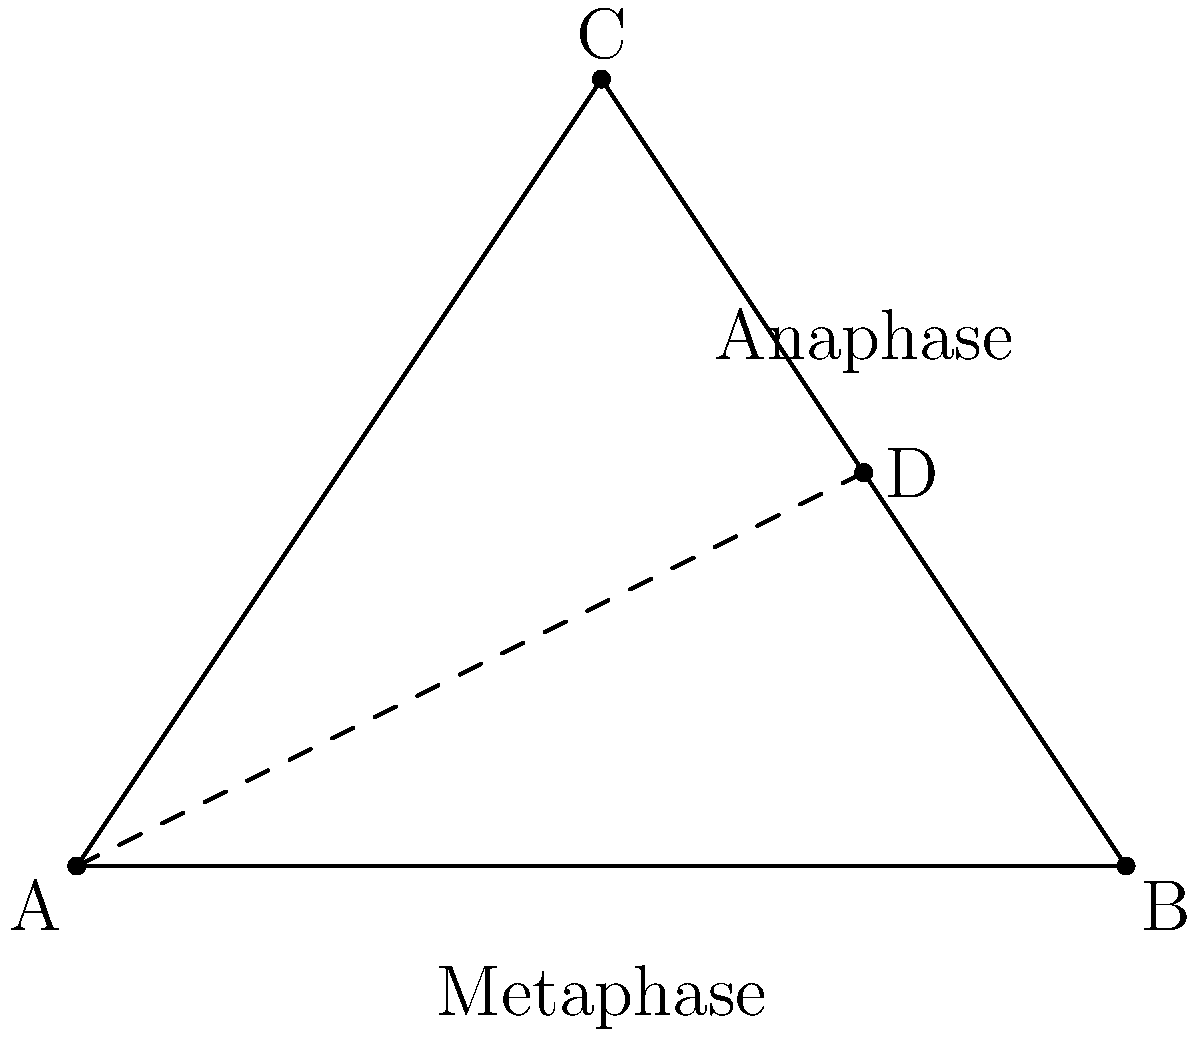In a novel exploring cellular biology, you describe the process of mitosis using geometric analogies. Consider the triangle ABC representing a cell at metaphase, with point D being the midpoint of BC. If the distance from A to D represents the movement of chromosomes during anaphase, and AB = 4 units, BC = 5 units, what is the length of AD to the nearest tenth? Let's approach this step-by-step:

1) First, we need to find the coordinates of point D. Since D is the midpoint of BC, its coordinates will be the average of B and C's coordinates.

2) We're given that AB = 4 units. If we place A at (0,0) and B at (4,0), then the base of the triangle is 4 units long.

3) To find the coordinates of C, we can use the Pythagorean theorem:
   $BC^2 = 5^2 = (4-x)^2 + y^2$, where (x,y) are the coordinates of C.

4) We also know that the area of the triangle can be calculated two ways:
   $\frac{1}{2} * 4 * y = \frac{1}{2} * 5 * 4 * \sin(\theta)$
   Where $\theta$ is the angle at B.

5) Solving these equations, we get C ≈ (2, 3).

6) Therefore, D is at ((4+2)/2, (0+3)/2) = (3, 1.5)

7) Now we can find AD using the distance formula:
   $AD = \sqrt{(3-0)^2 + (1.5-0)^2} = \sqrt{9 + 2.25} = \sqrt{11.25} ≈ 3.4$
Answer: 3.4 units 